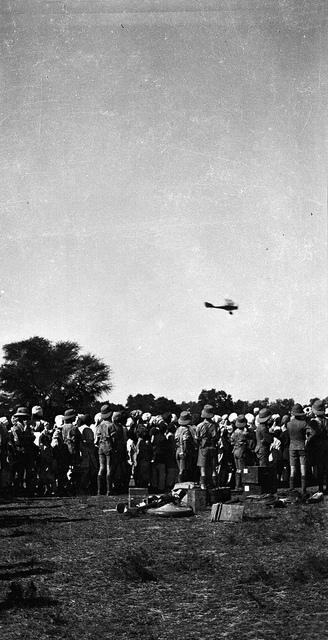How many sinks are there?
Give a very brief answer. 0. 